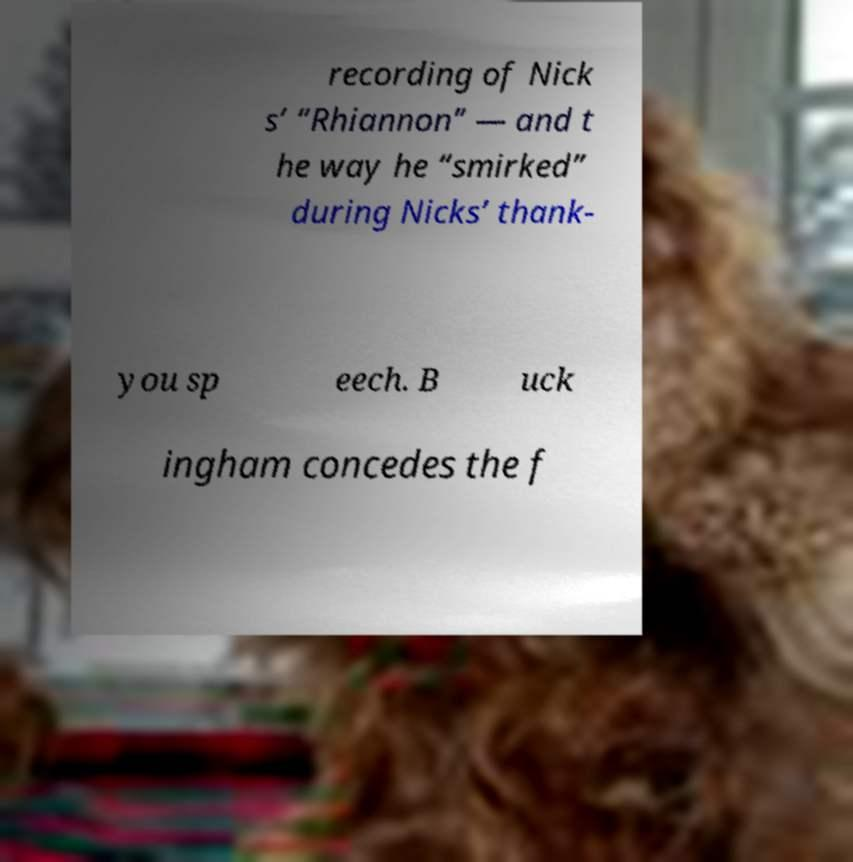Can you read and provide the text displayed in the image?This photo seems to have some interesting text. Can you extract and type it out for me? recording of Nick s’ “Rhiannon” — and t he way he “smirked” during Nicks’ thank- you sp eech. B uck ingham concedes the f 